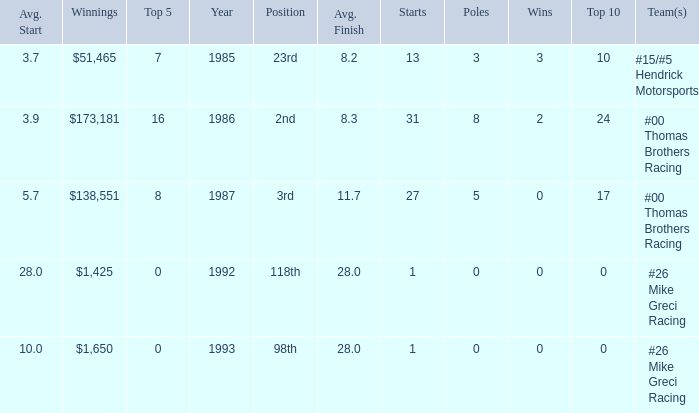What position did he finish in 1987? 3rd. 